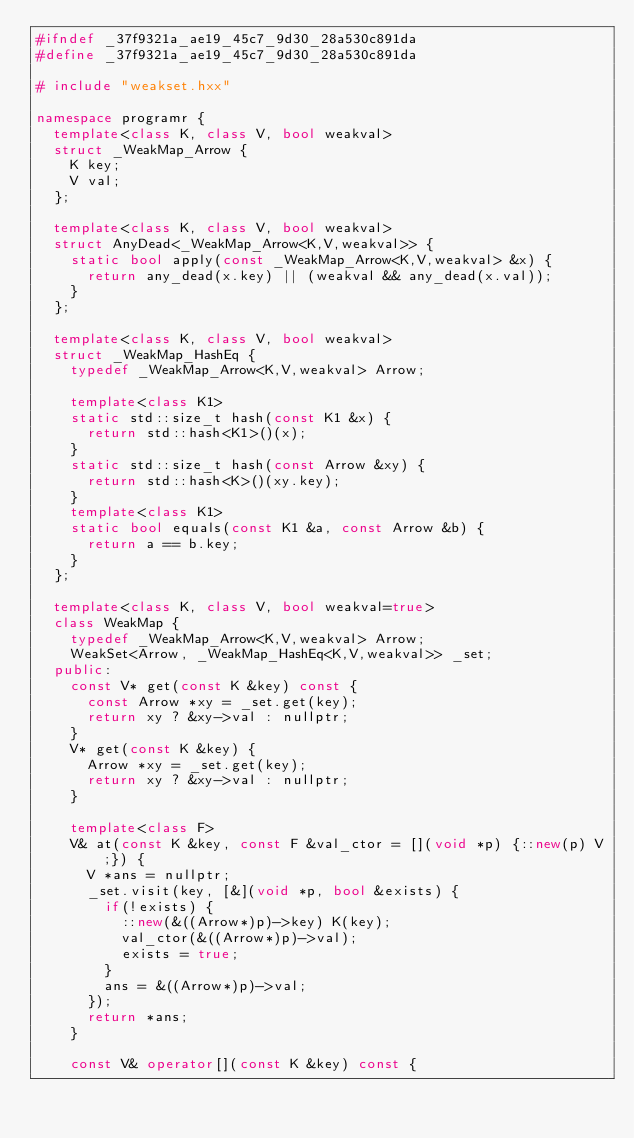<code> <loc_0><loc_0><loc_500><loc_500><_C++_>#ifndef _37f9321a_ae19_45c7_9d30_28a530c891da
#define _37f9321a_ae19_45c7_9d30_28a530c891da

# include "weakset.hxx"

namespace programr {
  template<class K, class V, bool weakval>
  struct _WeakMap_Arrow {
    K key;
    V val;
  };
  
  template<class K, class V, bool weakval>
  struct AnyDead<_WeakMap_Arrow<K,V,weakval>> {
    static bool apply(const _WeakMap_Arrow<K,V,weakval> &x) {
      return any_dead(x.key) || (weakval && any_dead(x.val));
    }
  };
  
  template<class K, class V, bool weakval>
  struct _WeakMap_HashEq {
    typedef _WeakMap_Arrow<K,V,weakval> Arrow;
    
    template<class K1>
    static std::size_t hash(const K1 &x) {
      return std::hash<K1>()(x);
    }
    static std::size_t hash(const Arrow &xy) {
      return std::hash<K>()(xy.key);
    }
    template<class K1>
    static bool equals(const K1 &a, const Arrow &b) {
      return a == b.key;
    }
  };
  
  template<class K, class V, bool weakval=true>
  class WeakMap {
    typedef _WeakMap_Arrow<K,V,weakval> Arrow;
    WeakSet<Arrow, _WeakMap_HashEq<K,V,weakval>> _set;
  public:
    const V* get(const K &key) const {
      const Arrow *xy = _set.get(key);
      return xy ? &xy->val : nullptr;
    }
    V* get(const K &key) {
      Arrow *xy = _set.get(key);
      return xy ? &xy->val : nullptr;
    }
    
    template<class F>
    V& at(const K &key, const F &val_ctor = [](void *p) {::new(p) V;}) {
      V *ans = nullptr;
      _set.visit(key, [&](void *p, bool &exists) {
        if(!exists) {
          ::new(&((Arrow*)p)->key) K(key);
          val_ctor(&((Arrow*)p)->val);
          exists = true;
        }
        ans = &((Arrow*)p)->val;
      });
      return *ans;
    }

    const V& operator[](const K &key) const {</code> 